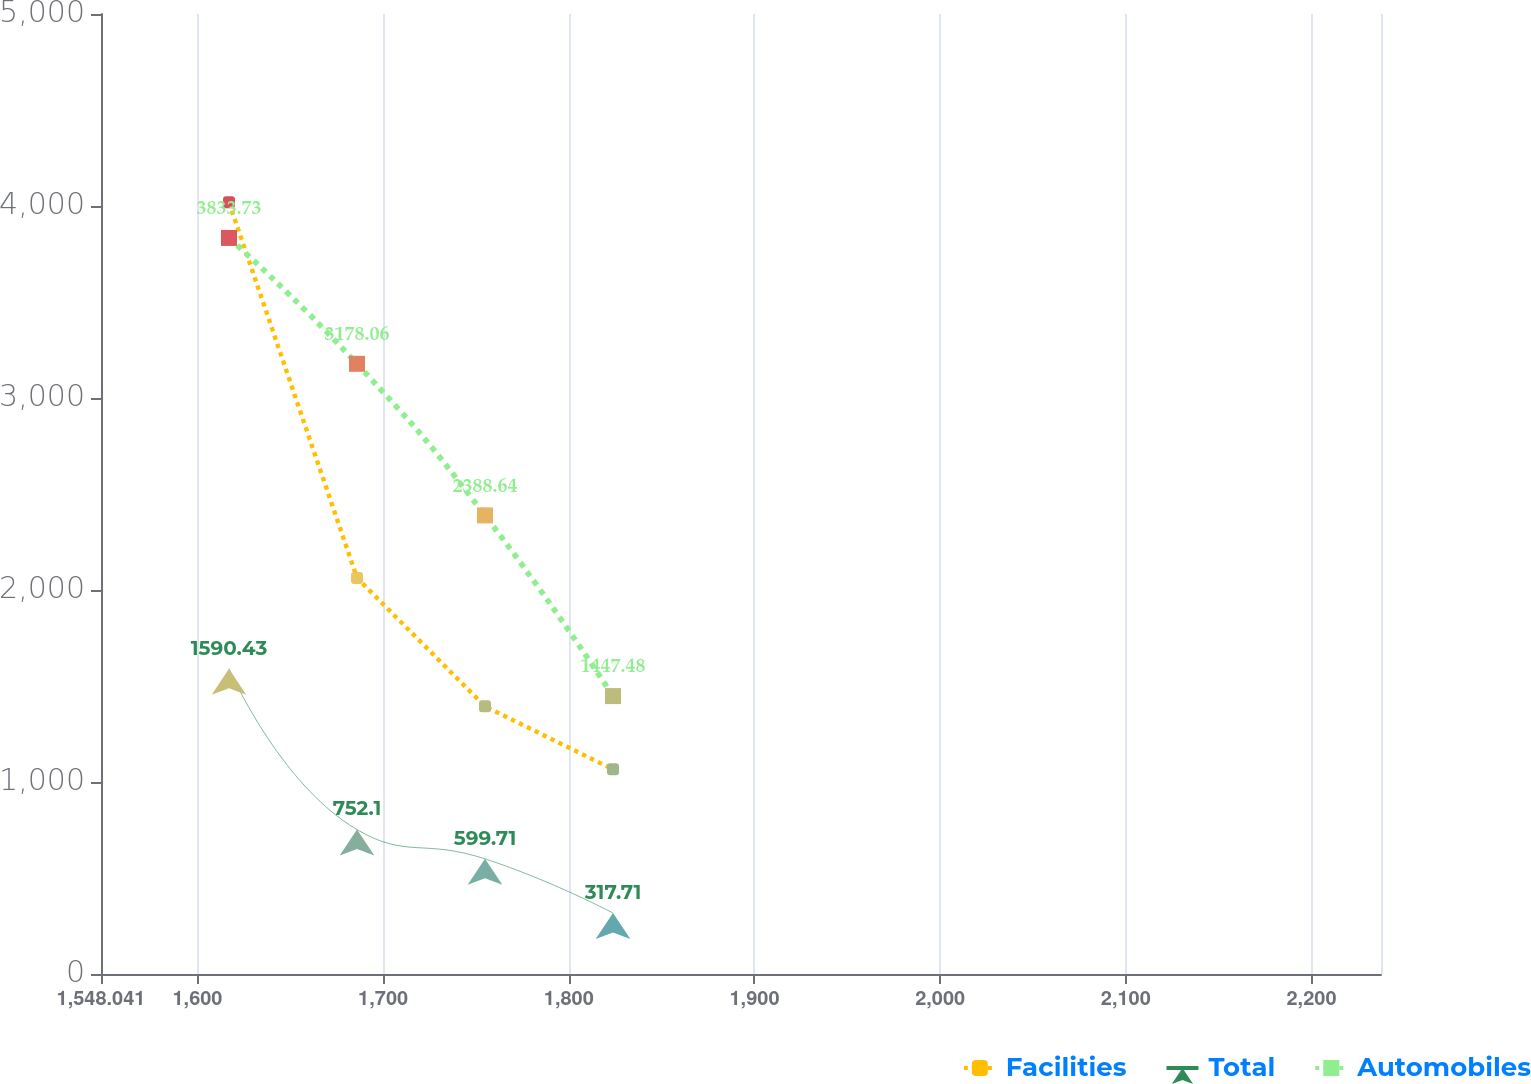Convert chart to OTSL. <chart><loc_0><loc_0><loc_500><loc_500><line_chart><ecel><fcel>Facilities<fcel>Total<fcel>Automobiles<nl><fcel>1616.98<fcel>4019.34<fcel>1590.43<fcel>3833.73<nl><fcel>1685.92<fcel>2063.1<fcel>752.1<fcel>3178.06<nl><fcel>1754.86<fcel>1393.94<fcel>599.71<fcel>2388.64<nl><fcel>1823.8<fcel>1065.76<fcel>317.71<fcel>1447.48<nl><fcel>2306.37<fcel>737.58<fcel>66.54<fcel>570.01<nl></chart> 